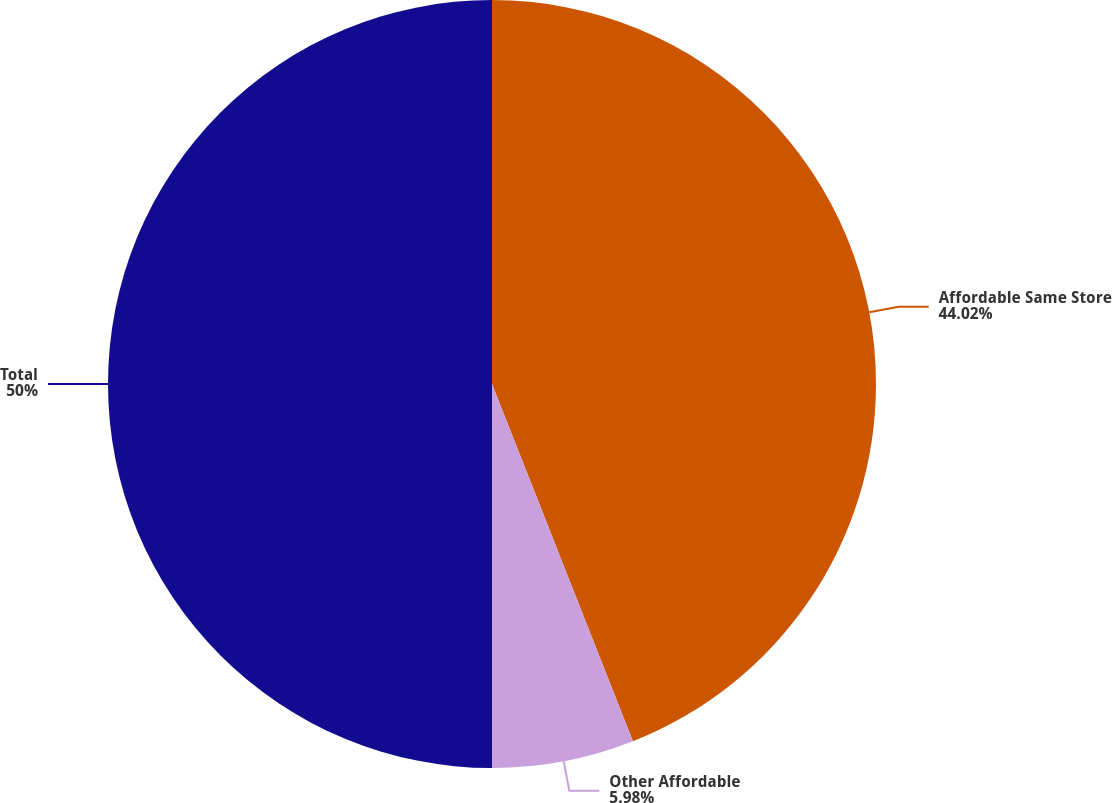Convert chart. <chart><loc_0><loc_0><loc_500><loc_500><pie_chart><fcel>Affordable Same Store<fcel>Other Affordable<fcel>Total<nl><fcel>44.02%<fcel>5.98%<fcel>50.0%<nl></chart> 